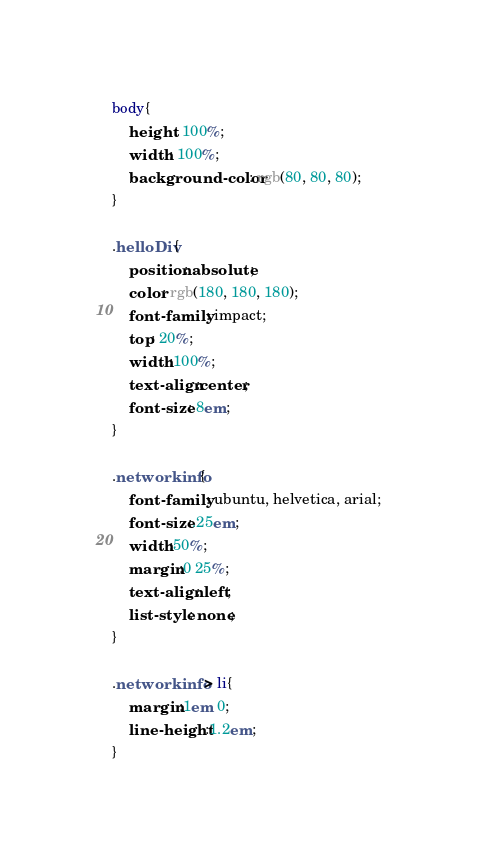<code> <loc_0><loc_0><loc_500><loc_500><_CSS_>body{
    height: 100%;
    width: 100%;
    background-color: rgb(80, 80, 80);
}

.helloDiv{
    position: absolute;
    color: rgb(180, 180, 180);
    font-family: impact;
    top: 20%;
    width:100%;
    text-align:center;
    font-size: 8em;
}

.networkinfo{
    font-family: ubuntu, helvetica, arial;
    font-size:.25em;
    width:50%;
    margin:0 25%;
    text-align: left;
    list-style: none;
}

.networkinfo > li{
    margin:1em 0;
    line-height:1.2em;
}
</code> 